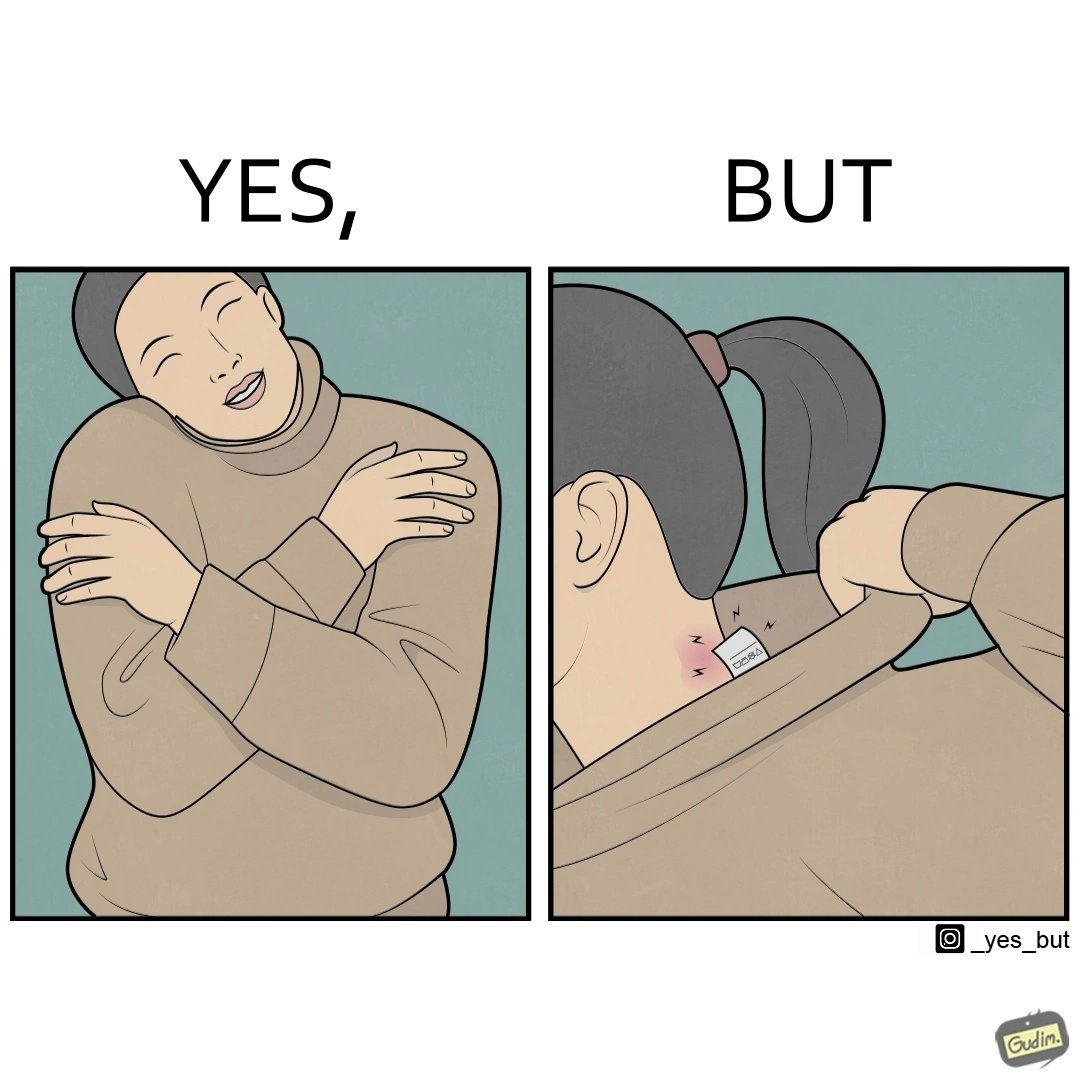Would you classify this image as satirical? Yes, this image is satirical. 